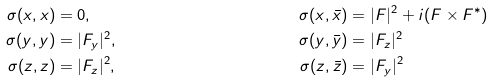<formula> <loc_0><loc_0><loc_500><loc_500>\sigma ( x , x ) & = 0 , & \sigma ( x , \bar { x } ) & = | F | ^ { 2 } + i ( F \times F ^ { \ast } ) \\ \sigma ( y , y ) & = | F _ { y } | ^ { 2 } , & \sigma ( y , \bar { y } ) & = | F _ { z } | ^ { 2 } \\ \sigma ( z , z ) & = | F _ { z } | ^ { 2 } , & \sigma ( z , \bar { z } ) & = | F _ { y } | ^ { 2 }</formula> 